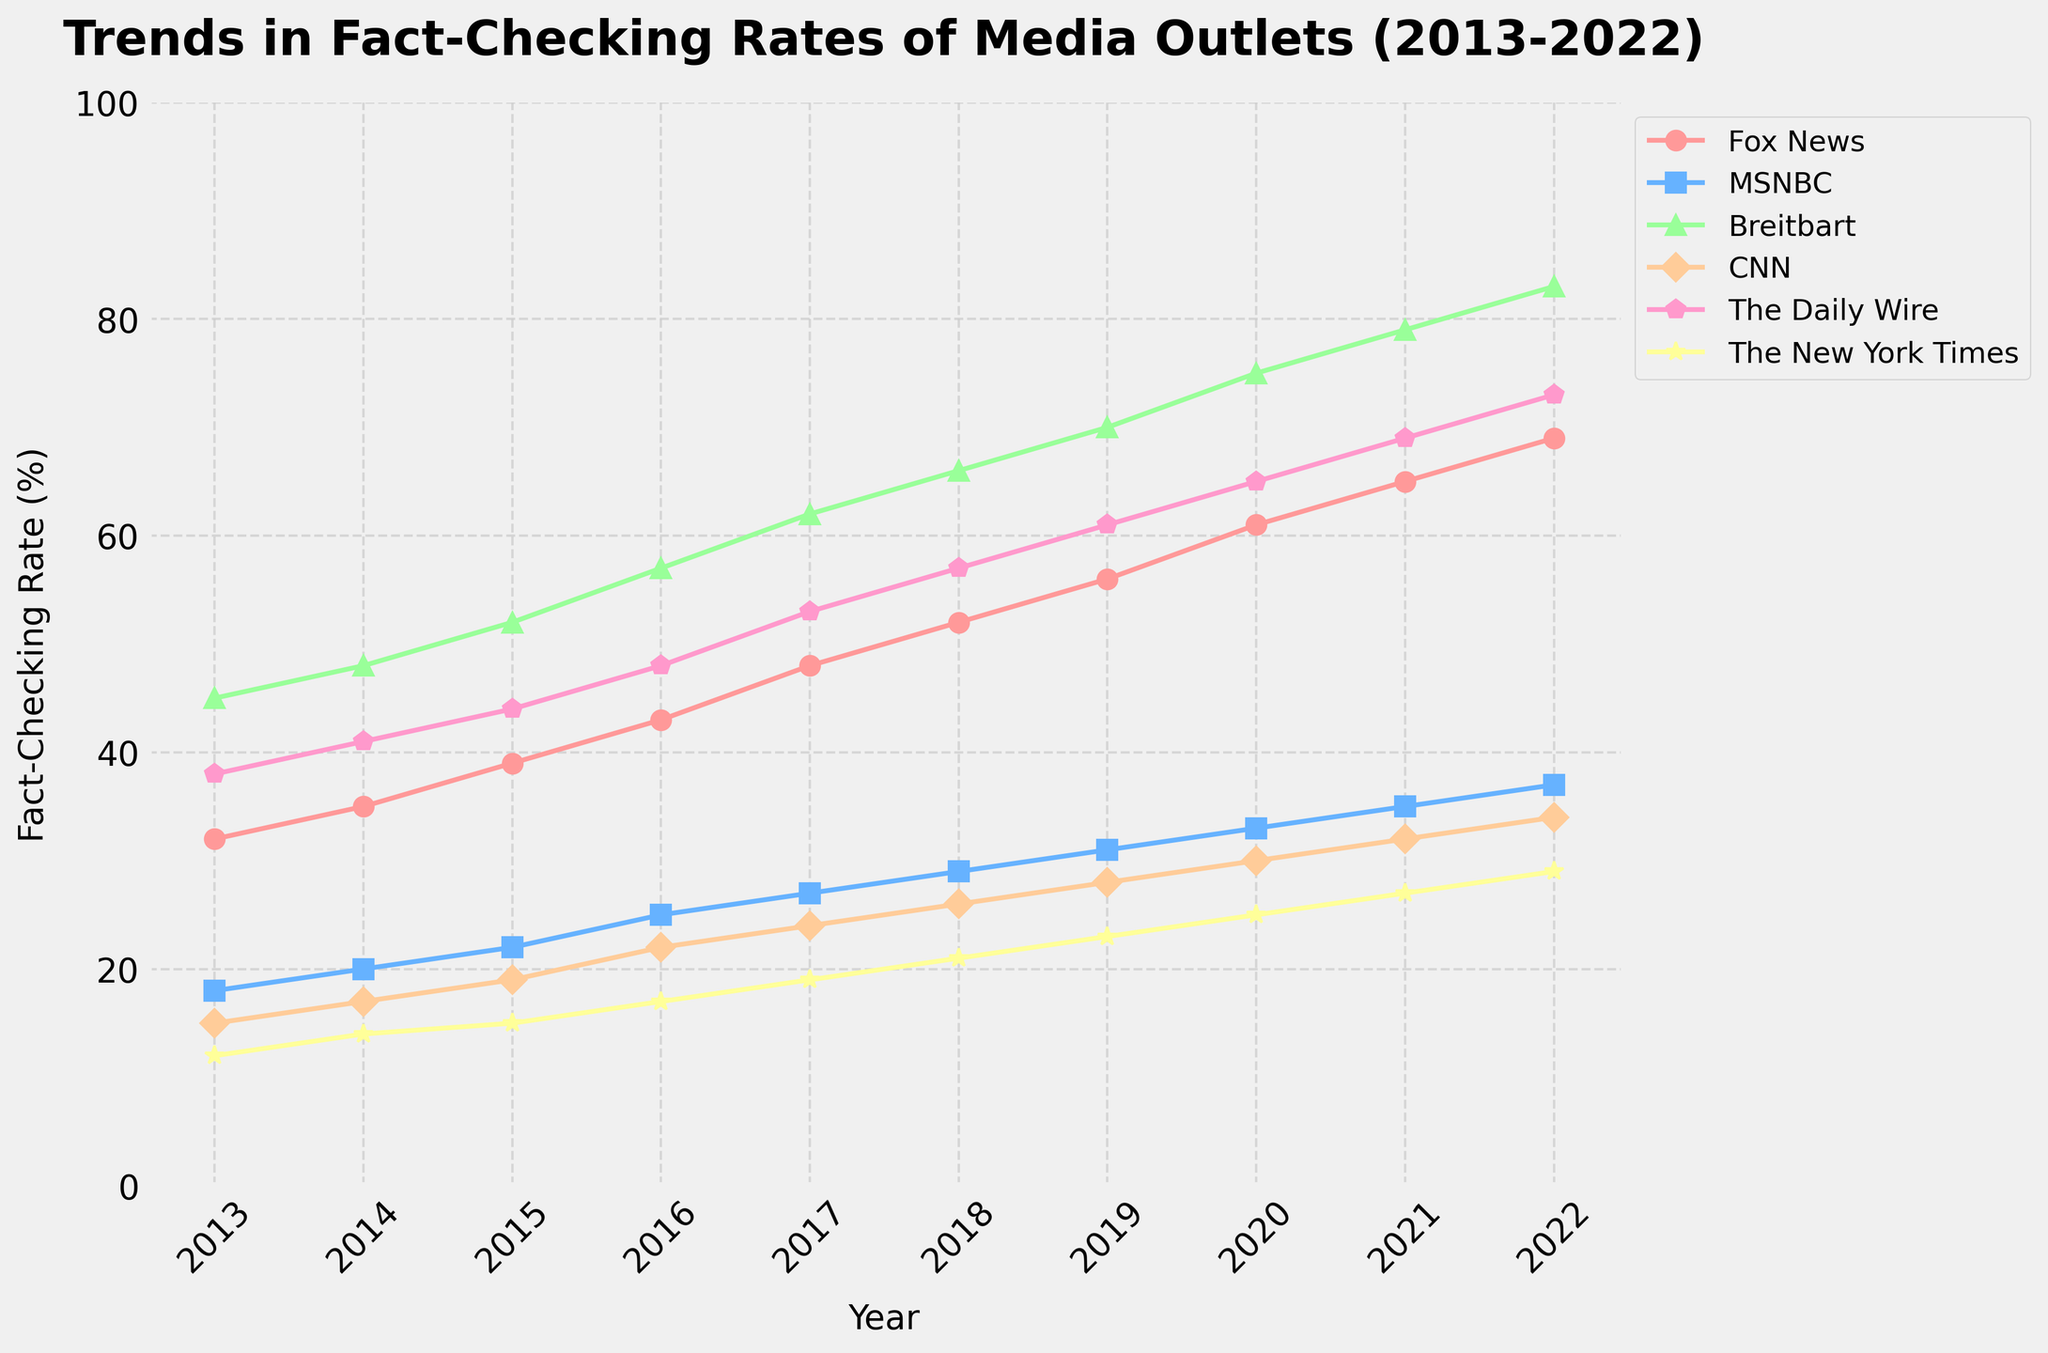Which media outlet had the highest fact-checking rate in 2022? Look at the endpoint values for each line on the graph. Find the one with the highest value. Breitbart has the highest value of 83% in 2022.
Answer: Breitbart Compare the trends of Fox News and CNN from 2013 to 2022. Which had a steeper increase in fact-checking rates? Calculate the difference between the endpoints (2022 and 2013) for both Fox News and CNN. Fox News had an increase from 32 to 69, and CNN had an increase from 15 to 34. 69 - 32 = 37 and 34 - 15 = 19, so Fox News had a steeper increase.
Answer: Fox News What's the average fact-checking rate for MSNBC over the decade? Add the fact-checking rates of MSNBC from 2013 to 2022 and divide by the number of years. (18 + 20 + 22 + 25 + 27 + 29 + 31 + 33 + 35 + 37) / 10 = 277 / 10 = 27.7
Answer: 27.7% Which year did The New York Times surpass both Fox News and CNN in fact-checking rate? Identify the years where The New York Times' line crosses above both Fox News' and CNN's lines. The New York Times never surpasses both Fox News and CNN in any year from 2013 to 2022.
Answer: Never Among the media outlets shown, which had the least variation in their fact-checking rates from 2013 to 2022? Calculate the range of fact-checking rates for each outlet and identify the smallest range. The New York Times ranges from 12 to 29 (29 - 12 = 17), which is the smallest variation compared to other media outlets.
Answer: The New York Times In which year did The Daily Wire's fact-checking rate equal CNN's rate? Find the point where the lines for The Daily Wire and CNN intersect. The Daily Wire's rate equals CNN's rate in 2015.
Answer: 2015 What's the median fact-checking rate for Fox News over the decade? List the fact-checking rates of Fox News from 2013 to 2022 in ascending order and find the middle value. For Fox News, the values in ascending order are 32, 35, 39, 43, 48, 52, 56, 61, 65, 69. The middle values are 48 and 52; average them. (48 + 52) / 2 = 50
Answer: 50 Which media outlet maintained the most consistent trend upward without any dips in their fact-checking rate? Look at the trend lines for each outlet to find the one that consistently increases each year without any drop. All except CNN show consistent upward trends, but Fox News trends upward most consistently.
Answer: Fox News 